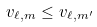Convert formula to latex. <formula><loc_0><loc_0><loc_500><loc_500>v _ { \ell , m } \leq v _ { \ell , m ^ { \prime } }</formula> 